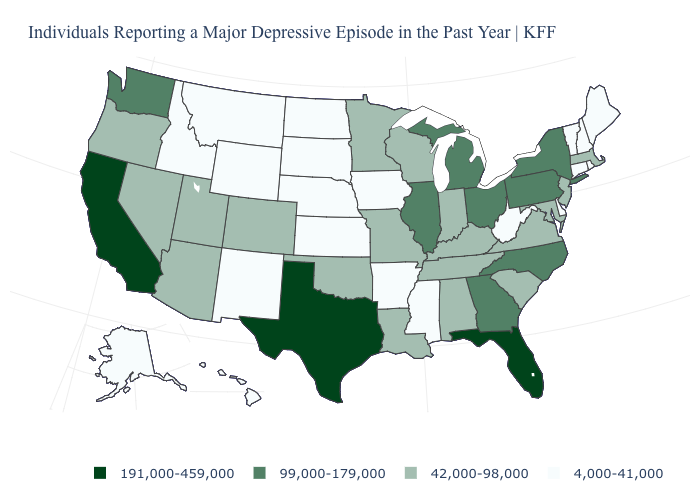Does the map have missing data?
Short answer required. No. What is the value of Mississippi?
Write a very short answer. 4,000-41,000. What is the value of Colorado?
Be succinct. 42,000-98,000. What is the value of New Mexico?
Answer briefly. 4,000-41,000. What is the lowest value in states that border New York?
Short answer required. 4,000-41,000. What is the value of Colorado?
Answer briefly. 42,000-98,000. Which states hav the highest value in the Northeast?
Answer briefly. New York, Pennsylvania. What is the highest value in the USA?
Short answer required. 191,000-459,000. Does South Dakota have the lowest value in the MidWest?
Quick response, please. Yes. What is the lowest value in the USA?
Short answer required. 4,000-41,000. Which states have the lowest value in the USA?
Concise answer only. Alaska, Arkansas, Connecticut, Delaware, Hawaii, Idaho, Iowa, Kansas, Maine, Mississippi, Montana, Nebraska, New Hampshire, New Mexico, North Dakota, Rhode Island, South Dakota, Vermont, West Virginia, Wyoming. Does the map have missing data?
Keep it brief. No. What is the value of South Carolina?
Quick response, please. 42,000-98,000. Name the states that have a value in the range 99,000-179,000?
Concise answer only. Georgia, Illinois, Michigan, New York, North Carolina, Ohio, Pennsylvania, Washington. Which states have the highest value in the USA?
Give a very brief answer. California, Florida, Texas. 